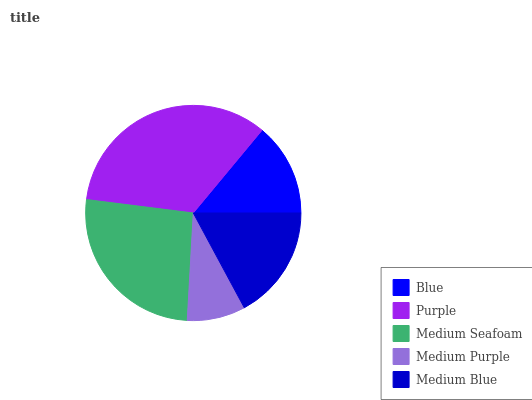Is Medium Purple the minimum?
Answer yes or no. Yes. Is Purple the maximum?
Answer yes or no. Yes. Is Medium Seafoam the minimum?
Answer yes or no. No. Is Medium Seafoam the maximum?
Answer yes or no. No. Is Purple greater than Medium Seafoam?
Answer yes or no. Yes. Is Medium Seafoam less than Purple?
Answer yes or no. Yes. Is Medium Seafoam greater than Purple?
Answer yes or no. No. Is Purple less than Medium Seafoam?
Answer yes or no. No. Is Medium Blue the high median?
Answer yes or no. Yes. Is Medium Blue the low median?
Answer yes or no. Yes. Is Medium Seafoam the high median?
Answer yes or no. No. Is Medium Seafoam the low median?
Answer yes or no. No. 